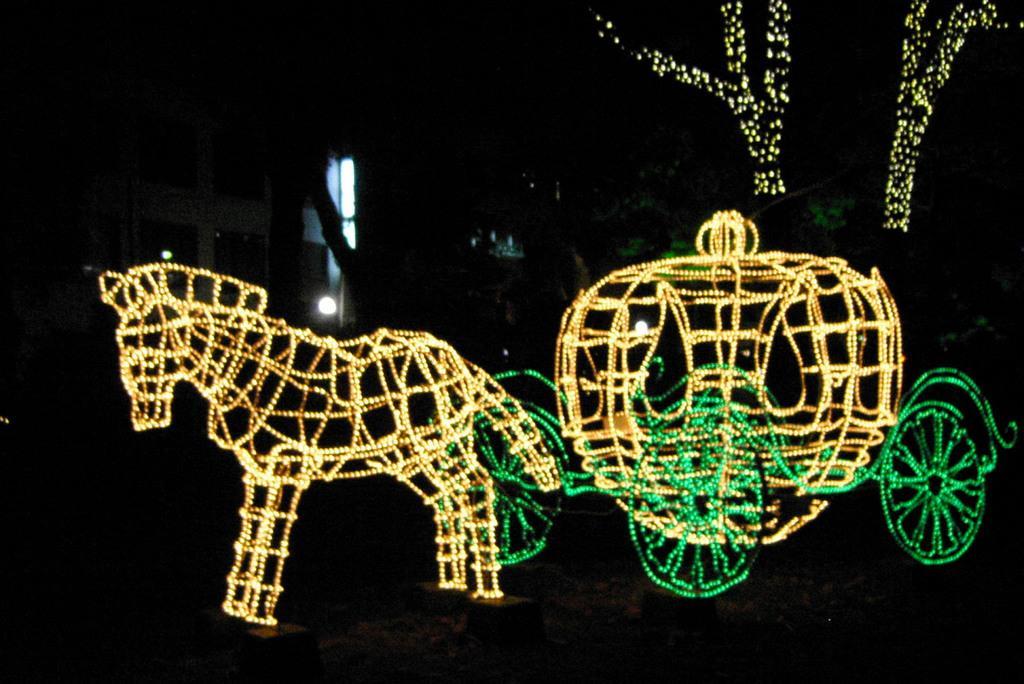Describe this image in one or two sentences. In this picture I can see a horse and a cart with rope lights and I can see a house and trees with lights in the back and I can sleep dark background. 